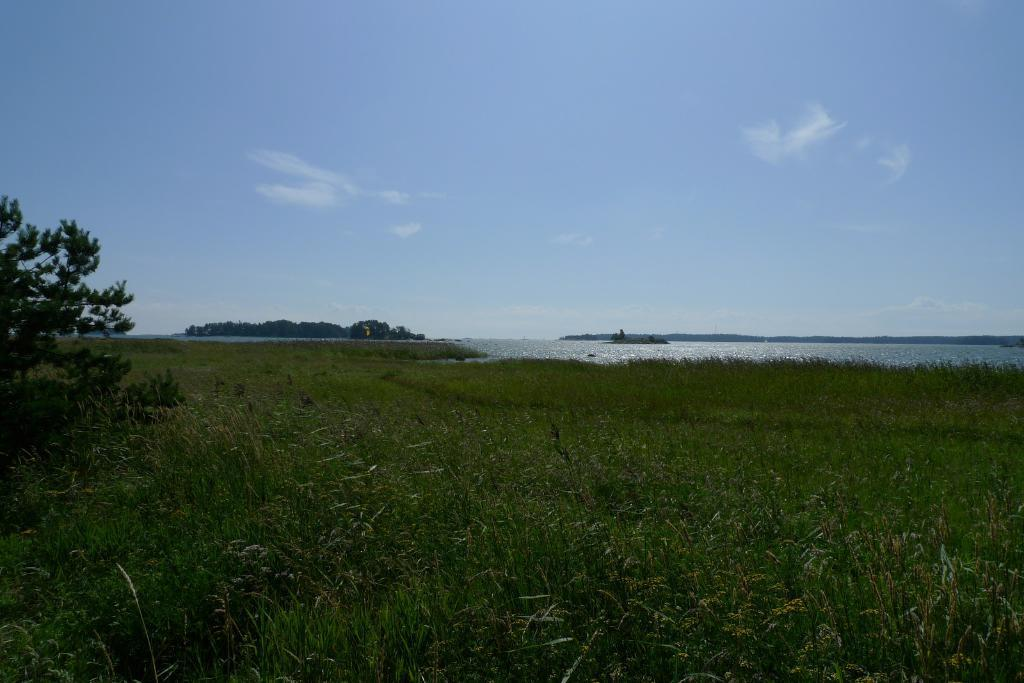What type of vegetation is present in the image? There is grass in the image, stretching from left to right. Can you describe any specific plants in the image? There is a plant on the left side of the image. What can be seen in the background of the image? There is greenery and water visible in the background. How would you describe the sky in the image? The sky is blue and cloudy. What type of yarn is the father using to fish in the image? There is no father or fishing activity present in the image. Can you tell me how many fish are visible in the image? There are no fish visible in the image. 